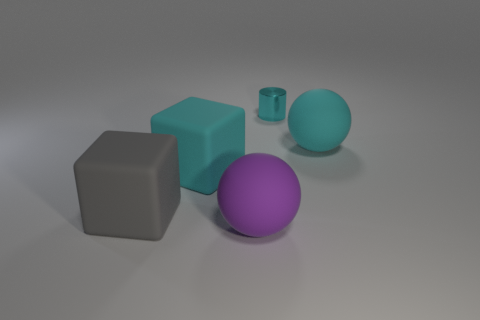Is there any other thing that has the same material as the cyan cylinder?
Keep it short and to the point. No. Are there fewer purple matte things that are left of the large gray rubber object than big purple cubes?
Provide a short and direct response. No. How many matte objects are big gray things or big purple cylinders?
Your response must be concise. 1. Is the shape of the large rubber thing that is to the right of the purple ball the same as the cyan matte thing that is to the left of the cyan shiny object?
Make the answer very short. No. What number of things are large gray matte cubes or objects that are to the right of the gray cube?
Keep it short and to the point. 5. What number of other things are there of the same size as the cyan block?
Your response must be concise. 3. Is the big ball that is behind the gray rubber object made of the same material as the small cyan object behind the gray matte cube?
Offer a terse response. No. There is a small cyan metal thing; what number of large cyan matte things are left of it?
Your response must be concise. 1. How many gray objects are tiny shiny cylinders or big matte objects?
Make the answer very short. 1. There is a cyan thing that is both on the right side of the big cyan cube and in front of the cylinder; what is its shape?
Give a very brief answer. Sphere. 